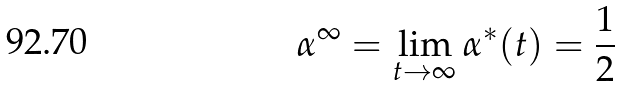Convert formula to latex. <formula><loc_0><loc_0><loc_500><loc_500>\alpha ^ { \infty } = \lim _ { t \to \infty } \alpha ^ { * } ( t ) = \frac { 1 } { 2 }</formula> 